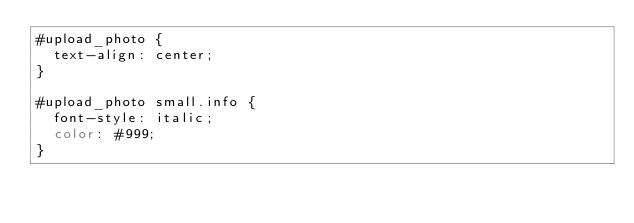Convert code to text. <code><loc_0><loc_0><loc_500><loc_500><_CSS_>#upload_photo {
  text-align: center;
}

#upload_photo small.info {
  font-style: italic;
  color: #999;
}</code> 